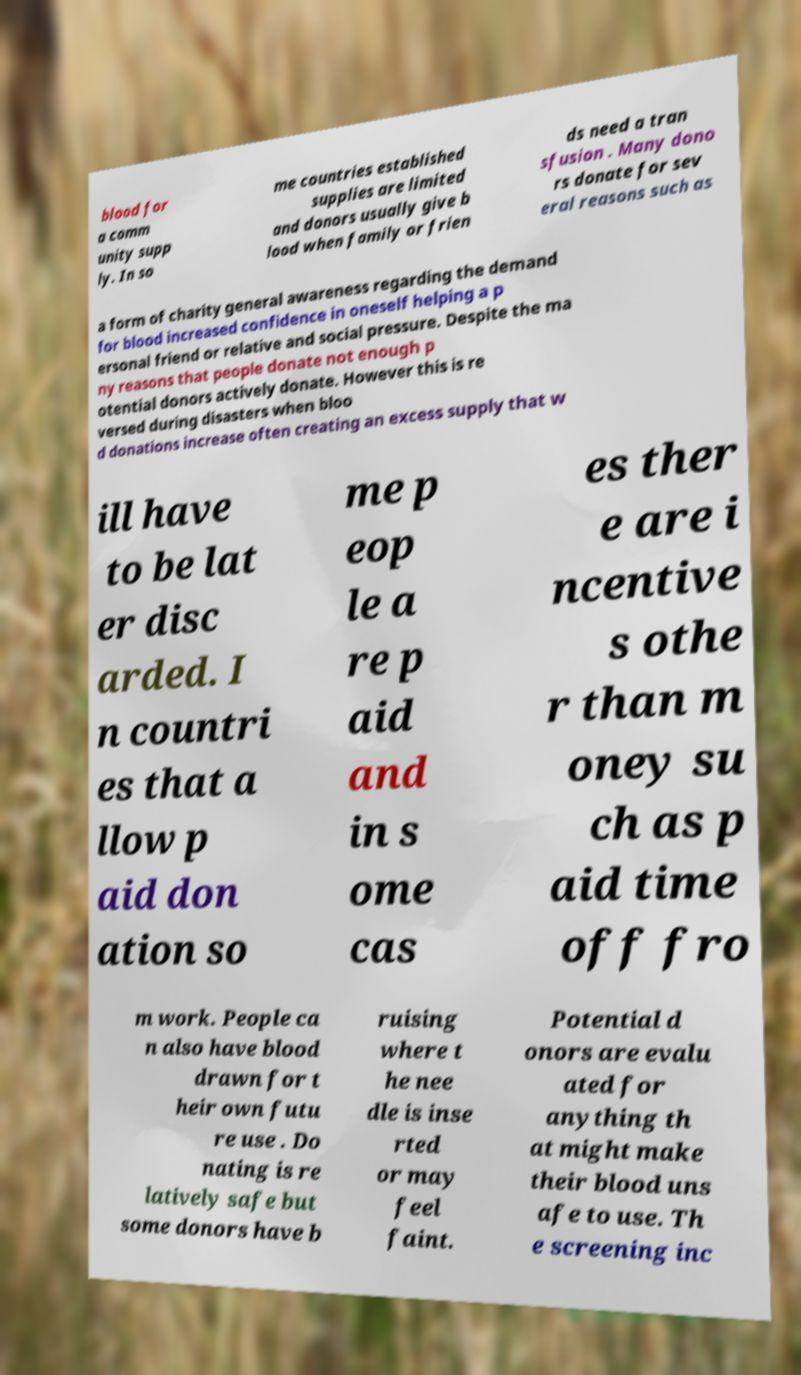Could you assist in decoding the text presented in this image and type it out clearly? blood for a comm unity supp ly. In so me countries established supplies are limited and donors usually give b lood when family or frien ds need a tran sfusion . Many dono rs donate for sev eral reasons such as a form of charity general awareness regarding the demand for blood increased confidence in oneself helping a p ersonal friend or relative and social pressure. Despite the ma ny reasons that people donate not enough p otential donors actively donate. However this is re versed during disasters when bloo d donations increase often creating an excess supply that w ill have to be lat er disc arded. I n countri es that a llow p aid don ation so me p eop le a re p aid and in s ome cas es ther e are i ncentive s othe r than m oney su ch as p aid time off fro m work. People ca n also have blood drawn for t heir own futu re use . Do nating is re latively safe but some donors have b ruising where t he nee dle is inse rted or may feel faint. Potential d onors are evalu ated for anything th at might make their blood uns afe to use. Th e screening inc 